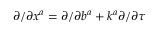<formula> <loc_0><loc_0><loc_500><loc_500>{ \partial } / { \partial x ^ { a } } = { \partial } / { \partial b ^ { a } } + k ^ { a } { \partial } / { \partial \tau }</formula> 